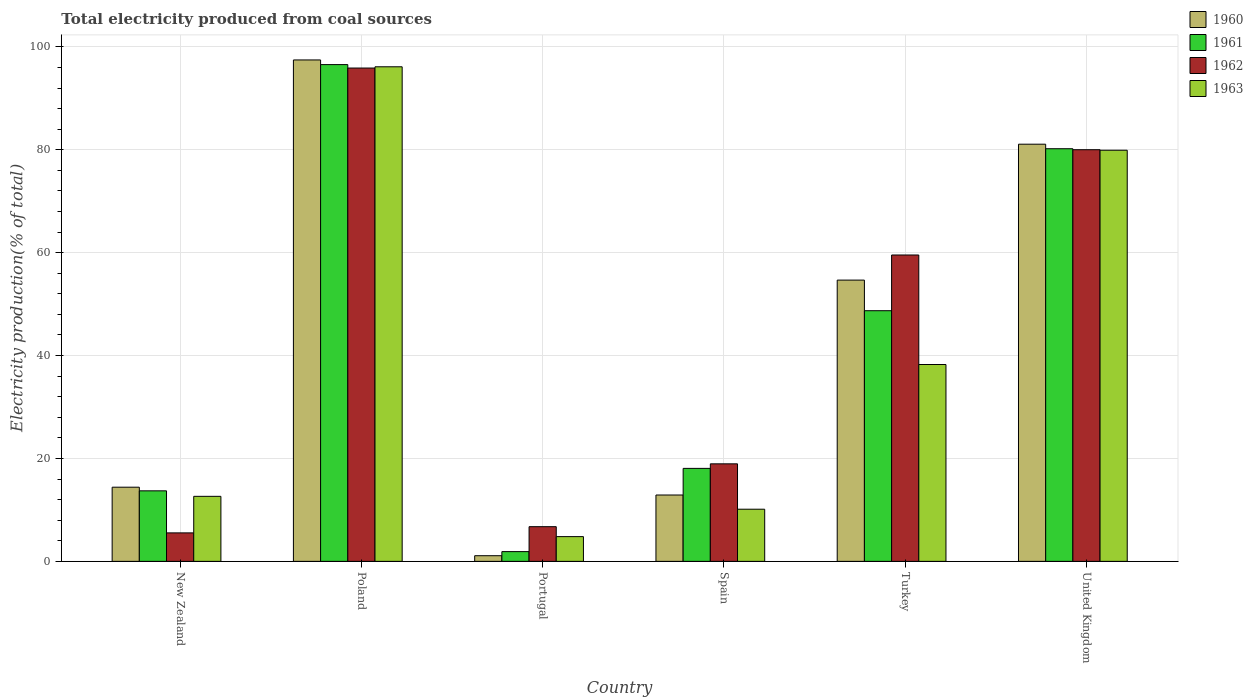How many bars are there on the 3rd tick from the left?
Keep it short and to the point. 4. What is the label of the 4th group of bars from the left?
Provide a succinct answer. Spain. In how many cases, is the number of bars for a given country not equal to the number of legend labels?
Offer a very short reply. 0. What is the total electricity produced in 1960 in Turkey?
Provide a succinct answer. 54.67. Across all countries, what is the maximum total electricity produced in 1960?
Your answer should be compact. 97.46. Across all countries, what is the minimum total electricity produced in 1961?
Ensure brevity in your answer.  1.89. What is the total total electricity produced in 1963 in the graph?
Provide a succinct answer. 241.89. What is the difference between the total electricity produced in 1960 in Turkey and that in United Kingdom?
Make the answer very short. -26.41. What is the difference between the total electricity produced in 1960 in New Zealand and the total electricity produced in 1961 in Portugal?
Provide a succinct answer. 12.52. What is the average total electricity produced in 1963 per country?
Provide a succinct answer. 40.32. What is the difference between the total electricity produced of/in 1963 and total electricity produced of/in 1961 in Portugal?
Your answer should be very brief. 2.91. What is the ratio of the total electricity produced in 1962 in Poland to that in United Kingdom?
Provide a succinct answer. 1.2. Is the total electricity produced in 1960 in New Zealand less than that in Portugal?
Keep it short and to the point. No. Is the difference between the total electricity produced in 1963 in Portugal and Turkey greater than the difference between the total electricity produced in 1961 in Portugal and Turkey?
Make the answer very short. Yes. What is the difference between the highest and the second highest total electricity produced in 1960?
Offer a very short reply. -16.38. What is the difference between the highest and the lowest total electricity produced in 1963?
Your answer should be compact. 91.32. In how many countries, is the total electricity produced in 1963 greater than the average total electricity produced in 1963 taken over all countries?
Provide a short and direct response. 2. Is the sum of the total electricity produced in 1962 in New Zealand and Turkey greater than the maximum total electricity produced in 1963 across all countries?
Offer a terse response. No. Is it the case that in every country, the sum of the total electricity produced in 1963 and total electricity produced in 1961 is greater than the sum of total electricity produced in 1960 and total electricity produced in 1962?
Your answer should be very brief. No. What does the 4th bar from the left in United Kingdom represents?
Offer a very short reply. 1963. What does the 2nd bar from the right in New Zealand represents?
Provide a short and direct response. 1962. How many bars are there?
Your response must be concise. 24. Are all the bars in the graph horizontal?
Your answer should be very brief. No. How many countries are there in the graph?
Make the answer very short. 6. Does the graph contain any zero values?
Ensure brevity in your answer.  No. Where does the legend appear in the graph?
Your response must be concise. Top right. How many legend labels are there?
Your response must be concise. 4. What is the title of the graph?
Your answer should be compact. Total electricity produced from coal sources. What is the label or title of the Y-axis?
Offer a very short reply. Electricity production(% of total). What is the Electricity production(% of total) of 1960 in New Zealand?
Provide a short and direct response. 14.42. What is the Electricity production(% of total) in 1961 in New Zealand?
Provide a short and direct response. 13.71. What is the Electricity production(% of total) in 1962 in New Zealand?
Ensure brevity in your answer.  5.54. What is the Electricity production(% of total) of 1963 in New Zealand?
Keep it short and to the point. 12.64. What is the Electricity production(% of total) in 1960 in Poland?
Your response must be concise. 97.46. What is the Electricity production(% of total) of 1961 in Poland?
Your answer should be very brief. 96.56. What is the Electricity production(% of total) in 1962 in Poland?
Provide a succinct answer. 95.89. What is the Electricity production(% of total) of 1963 in Poland?
Provide a short and direct response. 96.13. What is the Electricity production(% of total) in 1960 in Portugal?
Your response must be concise. 1.1. What is the Electricity production(% of total) of 1961 in Portugal?
Give a very brief answer. 1.89. What is the Electricity production(% of total) of 1962 in Portugal?
Your response must be concise. 6.74. What is the Electricity production(% of total) in 1963 in Portugal?
Keep it short and to the point. 4.81. What is the Electricity production(% of total) in 1960 in Spain?
Offer a terse response. 12.9. What is the Electricity production(% of total) in 1961 in Spain?
Give a very brief answer. 18.07. What is the Electricity production(% of total) in 1962 in Spain?
Make the answer very short. 18.96. What is the Electricity production(% of total) in 1963 in Spain?
Your response must be concise. 10.14. What is the Electricity production(% of total) of 1960 in Turkey?
Provide a short and direct response. 54.67. What is the Electricity production(% of total) in 1961 in Turkey?
Offer a very short reply. 48.72. What is the Electricity production(% of total) of 1962 in Turkey?
Your response must be concise. 59.55. What is the Electricity production(% of total) in 1963 in Turkey?
Give a very brief answer. 38.26. What is the Electricity production(% of total) of 1960 in United Kingdom?
Provide a short and direct response. 81.09. What is the Electricity production(% of total) of 1961 in United Kingdom?
Offer a terse response. 80.21. What is the Electricity production(% of total) in 1962 in United Kingdom?
Provide a succinct answer. 80.01. What is the Electricity production(% of total) in 1963 in United Kingdom?
Ensure brevity in your answer.  79.91. Across all countries, what is the maximum Electricity production(% of total) in 1960?
Provide a short and direct response. 97.46. Across all countries, what is the maximum Electricity production(% of total) of 1961?
Ensure brevity in your answer.  96.56. Across all countries, what is the maximum Electricity production(% of total) in 1962?
Your answer should be very brief. 95.89. Across all countries, what is the maximum Electricity production(% of total) in 1963?
Keep it short and to the point. 96.13. Across all countries, what is the minimum Electricity production(% of total) in 1960?
Keep it short and to the point. 1.1. Across all countries, what is the minimum Electricity production(% of total) in 1961?
Your answer should be compact. 1.89. Across all countries, what is the minimum Electricity production(% of total) in 1962?
Keep it short and to the point. 5.54. Across all countries, what is the minimum Electricity production(% of total) of 1963?
Provide a short and direct response. 4.81. What is the total Electricity production(% of total) of 1960 in the graph?
Your answer should be very brief. 261.63. What is the total Electricity production(% of total) in 1961 in the graph?
Ensure brevity in your answer.  259.16. What is the total Electricity production(% of total) of 1962 in the graph?
Your response must be concise. 266.69. What is the total Electricity production(% of total) in 1963 in the graph?
Make the answer very short. 241.89. What is the difference between the Electricity production(% of total) in 1960 in New Zealand and that in Poland?
Offer a terse response. -83.05. What is the difference between the Electricity production(% of total) of 1961 in New Zealand and that in Poland?
Make the answer very short. -82.85. What is the difference between the Electricity production(% of total) in 1962 in New Zealand and that in Poland?
Your answer should be compact. -90.35. What is the difference between the Electricity production(% of total) in 1963 in New Zealand and that in Poland?
Make the answer very short. -83.49. What is the difference between the Electricity production(% of total) of 1960 in New Zealand and that in Portugal?
Provide a succinct answer. 13.32. What is the difference between the Electricity production(% of total) of 1961 in New Zealand and that in Portugal?
Offer a very short reply. 11.81. What is the difference between the Electricity production(% of total) in 1962 in New Zealand and that in Portugal?
Your response must be concise. -1.2. What is the difference between the Electricity production(% of total) in 1963 in New Zealand and that in Portugal?
Your answer should be compact. 7.83. What is the difference between the Electricity production(% of total) in 1960 in New Zealand and that in Spain?
Your answer should be compact. 1.52. What is the difference between the Electricity production(% of total) of 1961 in New Zealand and that in Spain?
Offer a terse response. -4.36. What is the difference between the Electricity production(% of total) in 1962 in New Zealand and that in Spain?
Your answer should be compact. -13.42. What is the difference between the Electricity production(% of total) in 1963 in New Zealand and that in Spain?
Keep it short and to the point. 2.5. What is the difference between the Electricity production(% of total) in 1960 in New Zealand and that in Turkey?
Provide a short and direct response. -40.25. What is the difference between the Electricity production(% of total) of 1961 in New Zealand and that in Turkey?
Offer a terse response. -35.01. What is the difference between the Electricity production(% of total) in 1962 in New Zealand and that in Turkey?
Give a very brief answer. -54.01. What is the difference between the Electricity production(% of total) in 1963 in New Zealand and that in Turkey?
Ensure brevity in your answer.  -25.62. What is the difference between the Electricity production(% of total) in 1960 in New Zealand and that in United Kingdom?
Make the answer very short. -66.67. What is the difference between the Electricity production(% of total) of 1961 in New Zealand and that in United Kingdom?
Offer a very short reply. -66.5. What is the difference between the Electricity production(% of total) in 1962 in New Zealand and that in United Kingdom?
Keep it short and to the point. -74.48. What is the difference between the Electricity production(% of total) of 1963 in New Zealand and that in United Kingdom?
Provide a succinct answer. -67.27. What is the difference between the Electricity production(% of total) of 1960 in Poland and that in Portugal?
Your answer should be compact. 96.36. What is the difference between the Electricity production(% of total) of 1961 in Poland and that in Portugal?
Your answer should be very brief. 94.66. What is the difference between the Electricity production(% of total) in 1962 in Poland and that in Portugal?
Your answer should be very brief. 89.15. What is the difference between the Electricity production(% of total) of 1963 in Poland and that in Portugal?
Ensure brevity in your answer.  91.32. What is the difference between the Electricity production(% of total) of 1960 in Poland and that in Spain?
Ensure brevity in your answer.  84.56. What is the difference between the Electricity production(% of total) in 1961 in Poland and that in Spain?
Offer a terse response. 78.49. What is the difference between the Electricity production(% of total) in 1962 in Poland and that in Spain?
Ensure brevity in your answer.  76.93. What is the difference between the Electricity production(% of total) of 1963 in Poland and that in Spain?
Provide a succinct answer. 86. What is the difference between the Electricity production(% of total) in 1960 in Poland and that in Turkey?
Your answer should be compact. 42.79. What is the difference between the Electricity production(% of total) of 1961 in Poland and that in Turkey?
Your response must be concise. 47.84. What is the difference between the Electricity production(% of total) in 1962 in Poland and that in Turkey?
Provide a succinct answer. 36.34. What is the difference between the Electricity production(% of total) in 1963 in Poland and that in Turkey?
Offer a terse response. 57.87. What is the difference between the Electricity production(% of total) of 1960 in Poland and that in United Kingdom?
Offer a very short reply. 16.38. What is the difference between the Electricity production(% of total) in 1961 in Poland and that in United Kingdom?
Offer a terse response. 16.35. What is the difference between the Electricity production(% of total) in 1962 in Poland and that in United Kingdom?
Your response must be concise. 15.87. What is the difference between the Electricity production(% of total) in 1963 in Poland and that in United Kingdom?
Offer a terse response. 16.22. What is the difference between the Electricity production(% of total) in 1960 in Portugal and that in Spain?
Your answer should be compact. -11.8. What is the difference between the Electricity production(% of total) of 1961 in Portugal and that in Spain?
Make the answer very short. -16.18. What is the difference between the Electricity production(% of total) in 1962 in Portugal and that in Spain?
Your answer should be compact. -12.22. What is the difference between the Electricity production(% of total) of 1963 in Portugal and that in Spain?
Give a very brief answer. -5.33. What is the difference between the Electricity production(% of total) in 1960 in Portugal and that in Turkey?
Make the answer very short. -53.57. What is the difference between the Electricity production(% of total) of 1961 in Portugal and that in Turkey?
Your answer should be compact. -46.83. What is the difference between the Electricity production(% of total) in 1962 in Portugal and that in Turkey?
Provide a short and direct response. -52.81. What is the difference between the Electricity production(% of total) in 1963 in Portugal and that in Turkey?
Ensure brevity in your answer.  -33.45. What is the difference between the Electricity production(% of total) of 1960 in Portugal and that in United Kingdom?
Your answer should be very brief. -79.99. What is the difference between the Electricity production(% of total) in 1961 in Portugal and that in United Kingdom?
Provide a short and direct response. -78.31. What is the difference between the Electricity production(% of total) of 1962 in Portugal and that in United Kingdom?
Make the answer very short. -73.27. What is the difference between the Electricity production(% of total) in 1963 in Portugal and that in United Kingdom?
Make the answer very short. -75.1. What is the difference between the Electricity production(% of total) in 1960 in Spain and that in Turkey?
Your answer should be compact. -41.77. What is the difference between the Electricity production(% of total) of 1961 in Spain and that in Turkey?
Your answer should be very brief. -30.65. What is the difference between the Electricity production(% of total) in 1962 in Spain and that in Turkey?
Offer a very short reply. -40.59. What is the difference between the Electricity production(% of total) of 1963 in Spain and that in Turkey?
Offer a very short reply. -28.13. What is the difference between the Electricity production(% of total) of 1960 in Spain and that in United Kingdom?
Provide a short and direct response. -68.19. What is the difference between the Electricity production(% of total) in 1961 in Spain and that in United Kingdom?
Give a very brief answer. -62.14. What is the difference between the Electricity production(% of total) of 1962 in Spain and that in United Kingdom?
Your response must be concise. -61.06. What is the difference between the Electricity production(% of total) in 1963 in Spain and that in United Kingdom?
Keep it short and to the point. -69.78. What is the difference between the Electricity production(% of total) in 1960 in Turkey and that in United Kingdom?
Your response must be concise. -26.41. What is the difference between the Electricity production(% of total) in 1961 in Turkey and that in United Kingdom?
Provide a succinct answer. -31.49. What is the difference between the Electricity production(% of total) in 1962 in Turkey and that in United Kingdom?
Ensure brevity in your answer.  -20.46. What is the difference between the Electricity production(% of total) of 1963 in Turkey and that in United Kingdom?
Your answer should be compact. -41.65. What is the difference between the Electricity production(% of total) in 1960 in New Zealand and the Electricity production(% of total) in 1961 in Poland?
Your answer should be very brief. -82.14. What is the difference between the Electricity production(% of total) in 1960 in New Zealand and the Electricity production(% of total) in 1962 in Poland?
Ensure brevity in your answer.  -81.47. What is the difference between the Electricity production(% of total) in 1960 in New Zealand and the Electricity production(% of total) in 1963 in Poland?
Ensure brevity in your answer.  -81.71. What is the difference between the Electricity production(% of total) of 1961 in New Zealand and the Electricity production(% of total) of 1962 in Poland?
Your answer should be compact. -82.18. What is the difference between the Electricity production(% of total) of 1961 in New Zealand and the Electricity production(% of total) of 1963 in Poland?
Your answer should be compact. -82.42. What is the difference between the Electricity production(% of total) in 1962 in New Zealand and the Electricity production(% of total) in 1963 in Poland?
Your response must be concise. -90.6. What is the difference between the Electricity production(% of total) in 1960 in New Zealand and the Electricity production(% of total) in 1961 in Portugal?
Ensure brevity in your answer.  12.52. What is the difference between the Electricity production(% of total) in 1960 in New Zealand and the Electricity production(% of total) in 1962 in Portugal?
Offer a very short reply. 7.68. What is the difference between the Electricity production(% of total) in 1960 in New Zealand and the Electricity production(% of total) in 1963 in Portugal?
Provide a succinct answer. 9.61. What is the difference between the Electricity production(% of total) in 1961 in New Zealand and the Electricity production(% of total) in 1962 in Portugal?
Provide a succinct answer. 6.97. What is the difference between the Electricity production(% of total) in 1961 in New Zealand and the Electricity production(% of total) in 1963 in Portugal?
Provide a short and direct response. 8.9. What is the difference between the Electricity production(% of total) in 1962 in New Zealand and the Electricity production(% of total) in 1963 in Portugal?
Offer a very short reply. 0.73. What is the difference between the Electricity production(% of total) in 1960 in New Zealand and the Electricity production(% of total) in 1961 in Spain?
Offer a terse response. -3.65. What is the difference between the Electricity production(% of total) in 1960 in New Zealand and the Electricity production(% of total) in 1962 in Spain?
Keep it short and to the point. -4.54. What is the difference between the Electricity production(% of total) of 1960 in New Zealand and the Electricity production(% of total) of 1963 in Spain?
Provide a short and direct response. 4.28. What is the difference between the Electricity production(% of total) of 1961 in New Zealand and the Electricity production(% of total) of 1962 in Spain?
Make the answer very short. -5.25. What is the difference between the Electricity production(% of total) in 1961 in New Zealand and the Electricity production(% of total) in 1963 in Spain?
Ensure brevity in your answer.  3.57. What is the difference between the Electricity production(% of total) in 1962 in New Zealand and the Electricity production(% of total) in 1963 in Spain?
Offer a terse response. -4.6. What is the difference between the Electricity production(% of total) of 1960 in New Zealand and the Electricity production(% of total) of 1961 in Turkey?
Keep it short and to the point. -34.3. What is the difference between the Electricity production(% of total) of 1960 in New Zealand and the Electricity production(% of total) of 1962 in Turkey?
Make the answer very short. -45.13. What is the difference between the Electricity production(% of total) in 1960 in New Zealand and the Electricity production(% of total) in 1963 in Turkey?
Provide a succinct answer. -23.85. What is the difference between the Electricity production(% of total) of 1961 in New Zealand and the Electricity production(% of total) of 1962 in Turkey?
Your response must be concise. -45.84. What is the difference between the Electricity production(% of total) in 1961 in New Zealand and the Electricity production(% of total) in 1963 in Turkey?
Provide a short and direct response. -24.55. What is the difference between the Electricity production(% of total) of 1962 in New Zealand and the Electricity production(% of total) of 1963 in Turkey?
Ensure brevity in your answer.  -32.73. What is the difference between the Electricity production(% of total) in 1960 in New Zealand and the Electricity production(% of total) in 1961 in United Kingdom?
Keep it short and to the point. -65.79. What is the difference between the Electricity production(% of total) of 1960 in New Zealand and the Electricity production(% of total) of 1962 in United Kingdom?
Provide a succinct answer. -65.6. What is the difference between the Electricity production(% of total) in 1960 in New Zealand and the Electricity production(% of total) in 1963 in United Kingdom?
Ensure brevity in your answer.  -65.5. What is the difference between the Electricity production(% of total) in 1961 in New Zealand and the Electricity production(% of total) in 1962 in United Kingdom?
Ensure brevity in your answer.  -66.31. What is the difference between the Electricity production(% of total) of 1961 in New Zealand and the Electricity production(% of total) of 1963 in United Kingdom?
Provide a short and direct response. -66.21. What is the difference between the Electricity production(% of total) of 1962 in New Zealand and the Electricity production(% of total) of 1963 in United Kingdom?
Keep it short and to the point. -74.38. What is the difference between the Electricity production(% of total) of 1960 in Poland and the Electricity production(% of total) of 1961 in Portugal?
Your response must be concise. 95.57. What is the difference between the Electricity production(% of total) in 1960 in Poland and the Electricity production(% of total) in 1962 in Portugal?
Your answer should be very brief. 90.72. What is the difference between the Electricity production(% of total) of 1960 in Poland and the Electricity production(% of total) of 1963 in Portugal?
Your response must be concise. 92.65. What is the difference between the Electricity production(% of total) of 1961 in Poland and the Electricity production(% of total) of 1962 in Portugal?
Provide a succinct answer. 89.82. What is the difference between the Electricity production(% of total) in 1961 in Poland and the Electricity production(% of total) in 1963 in Portugal?
Give a very brief answer. 91.75. What is the difference between the Electricity production(% of total) of 1962 in Poland and the Electricity production(% of total) of 1963 in Portugal?
Provide a succinct answer. 91.08. What is the difference between the Electricity production(% of total) in 1960 in Poland and the Electricity production(% of total) in 1961 in Spain?
Your answer should be very brief. 79.39. What is the difference between the Electricity production(% of total) of 1960 in Poland and the Electricity production(% of total) of 1962 in Spain?
Your answer should be compact. 78.51. What is the difference between the Electricity production(% of total) of 1960 in Poland and the Electricity production(% of total) of 1963 in Spain?
Keep it short and to the point. 87.33. What is the difference between the Electricity production(% of total) in 1961 in Poland and the Electricity production(% of total) in 1962 in Spain?
Make the answer very short. 77.6. What is the difference between the Electricity production(% of total) in 1961 in Poland and the Electricity production(% of total) in 1963 in Spain?
Provide a succinct answer. 86.42. What is the difference between the Electricity production(% of total) in 1962 in Poland and the Electricity production(% of total) in 1963 in Spain?
Your response must be concise. 85.75. What is the difference between the Electricity production(% of total) of 1960 in Poland and the Electricity production(% of total) of 1961 in Turkey?
Provide a short and direct response. 48.74. What is the difference between the Electricity production(% of total) in 1960 in Poland and the Electricity production(% of total) in 1962 in Turkey?
Your answer should be very brief. 37.91. What is the difference between the Electricity production(% of total) in 1960 in Poland and the Electricity production(% of total) in 1963 in Turkey?
Offer a very short reply. 59.2. What is the difference between the Electricity production(% of total) of 1961 in Poland and the Electricity production(% of total) of 1962 in Turkey?
Your response must be concise. 37.01. What is the difference between the Electricity production(% of total) of 1961 in Poland and the Electricity production(% of total) of 1963 in Turkey?
Your response must be concise. 58.29. What is the difference between the Electricity production(% of total) of 1962 in Poland and the Electricity production(% of total) of 1963 in Turkey?
Your answer should be very brief. 57.63. What is the difference between the Electricity production(% of total) in 1960 in Poland and the Electricity production(% of total) in 1961 in United Kingdom?
Provide a short and direct response. 17.26. What is the difference between the Electricity production(% of total) of 1960 in Poland and the Electricity production(% of total) of 1962 in United Kingdom?
Offer a terse response. 17.45. What is the difference between the Electricity production(% of total) of 1960 in Poland and the Electricity production(% of total) of 1963 in United Kingdom?
Your answer should be compact. 17.55. What is the difference between the Electricity production(% of total) in 1961 in Poland and the Electricity production(% of total) in 1962 in United Kingdom?
Give a very brief answer. 16.54. What is the difference between the Electricity production(% of total) in 1961 in Poland and the Electricity production(% of total) in 1963 in United Kingdom?
Offer a terse response. 16.64. What is the difference between the Electricity production(% of total) of 1962 in Poland and the Electricity production(% of total) of 1963 in United Kingdom?
Ensure brevity in your answer.  15.97. What is the difference between the Electricity production(% of total) in 1960 in Portugal and the Electricity production(% of total) in 1961 in Spain?
Your answer should be very brief. -16.97. What is the difference between the Electricity production(% of total) of 1960 in Portugal and the Electricity production(% of total) of 1962 in Spain?
Provide a short and direct response. -17.86. What is the difference between the Electricity production(% of total) in 1960 in Portugal and the Electricity production(% of total) in 1963 in Spain?
Your answer should be compact. -9.04. What is the difference between the Electricity production(% of total) of 1961 in Portugal and the Electricity production(% of total) of 1962 in Spain?
Your answer should be compact. -17.06. What is the difference between the Electricity production(% of total) of 1961 in Portugal and the Electricity production(% of total) of 1963 in Spain?
Provide a short and direct response. -8.24. What is the difference between the Electricity production(% of total) of 1962 in Portugal and the Electricity production(% of total) of 1963 in Spain?
Offer a very short reply. -3.4. What is the difference between the Electricity production(% of total) in 1960 in Portugal and the Electricity production(% of total) in 1961 in Turkey?
Your answer should be compact. -47.62. What is the difference between the Electricity production(% of total) of 1960 in Portugal and the Electricity production(% of total) of 1962 in Turkey?
Offer a terse response. -58.45. What is the difference between the Electricity production(% of total) in 1960 in Portugal and the Electricity production(% of total) in 1963 in Turkey?
Your answer should be compact. -37.16. What is the difference between the Electricity production(% of total) of 1961 in Portugal and the Electricity production(% of total) of 1962 in Turkey?
Give a very brief answer. -57.66. What is the difference between the Electricity production(% of total) in 1961 in Portugal and the Electricity production(% of total) in 1963 in Turkey?
Your answer should be compact. -36.37. What is the difference between the Electricity production(% of total) in 1962 in Portugal and the Electricity production(% of total) in 1963 in Turkey?
Provide a succinct answer. -31.52. What is the difference between the Electricity production(% of total) of 1960 in Portugal and the Electricity production(% of total) of 1961 in United Kingdom?
Provide a short and direct response. -79.11. What is the difference between the Electricity production(% of total) of 1960 in Portugal and the Electricity production(% of total) of 1962 in United Kingdom?
Your answer should be very brief. -78.92. What is the difference between the Electricity production(% of total) in 1960 in Portugal and the Electricity production(% of total) in 1963 in United Kingdom?
Offer a very short reply. -78.82. What is the difference between the Electricity production(% of total) of 1961 in Portugal and the Electricity production(% of total) of 1962 in United Kingdom?
Provide a succinct answer. -78.12. What is the difference between the Electricity production(% of total) in 1961 in Portugal and the Electricity production(% of total) in 1963 in United Kingdom?
Your answer should be compact. -78.02. What is the difference between the Electricity production(% of total) in 1962 in Portugal and the Electricity production(% of total) in 1963 in United Kingdom?
Ensure brevity in your answer.  -73.17. What is the difference between the Electricity production(% of total) of 1960 in Spain and the Electricity production(% of total) of 1961 in Turkey?
Provide a succinct answer. -35.82. What is the difference between the Electricity production(% of total) in 1960 in Spain and the Electricity production(% of total) in 1962 in Turkey?
Ensure brevity in your answer.  -46.65. What is the difference between the Electricity production(% of total) in 1960 in Spain and the Electricity production(% of total) in 1963 in Turkey?
Your answer should be very brief. -25.36. What is the difference between the Electricity production(% of total) of 1961 in Spain and the Electricity production(% of total) of 1962 in Turkey?
Your response must be concise. -41.48. What is the difference between the Electricity production(% of total) in 1961 in Spain and the Electricity production(% of total) in 1963 in Turkey?
Provide a short and direct response. -20.19. What is the difference between the Electricity production(% of total) in 1962 in Spain and the Electricity production(% of total) in 1963 in Turkey?
Give a very brief answer. -19.31. What is the difference between the Electricity production(% of total) in 1960 in Spain and the Electricity production(% of total) in 1961 in United Kingdom?
Your answer should be very brief. -67.31. What is the difference between the Electricity production(% of total) in 1960 in Spain and the Electricity production(% of total) in 1962 in United Kingdom?
Provide a short and direct response. -67.12. What is the difference between the Electricity production(% of total) in 1960 in Spain and the Electricity production(% of total) in 1963 in United Kingdom?
Keep it short and to the point. -67.02. What is the difference between the Electricity production(% of total) of 1961 in Spain and the Electricity production(% of total) of 1962 in United Kingdom?
Your answer should be very brief. -61.94. What is the difference between the Electricity production(% of total) in 1961 in Spain and the Electricity production(% of total) in 1963 in United Kingdom?
Your answer should be compact. -61.84. What is the difference between the Electricity production(% of total) in 1962 in Spain and the Electricity production(% of total) in 1963 in United Kingdom?
Provide a short and direct response. -60.96. What is the difference between the Electricity production(% of total) of 1960 in Turkey and the Electricity production(% of total) of 1961 in United Kingdom?
Keep it short and to the point. -25.54. What is the difference between the Electricity production(% of total) of 1960 in Turkey and the Electricity production(% of total) of 1962 in United Kingdom?
Ensure brevity in your answer.  -25.34. What is the difference between the Electricity production(% of total) in 1960 in Turkey and the Electricity production(% of total) in 1963 in United Kingdom?
Make the answer very short. -25.24. What is the difference between the Electricity production(% of total) in 1961 in Turkey and the Electricity production(% of total) in 1962 in United Kingdom?
Keep it short and to the point. -31.29. What is the difference between the Electricity production(% of total) in 1961 in Turkey and the Electricity production(% of total) in 1963 in United Kingdom?
Make the answer very short. -31.19. What is the difference between the Electricity production(% of total) of 1962 in Turkey and the Electricity production(% of total) of 1963 in United Kingdom?
Offer a very short reply. -20.36. What is the average Electricity production(% of total) in 1960 per country?
Ensure brevity in your answer.  43.61. What is the average Electricity production(% of total) in 1961 per country?
Your answer should be very brief. 43.19. What is the average Electricity production(% of total) in 1962 per country?
Make the answer very short. 44.45. What is the average Electricity production(% of total) in 1963 per country?
Your answer should be compact. 40.32. What is the difference between the Electricity production(% of total) in 1960 and Electricity production(% of total) in 1961 in New Zealand?
Offer a terse response. 0.71. What is the difference between the Electricity production(% of total) of 1960 and Electricity production(% of total) of 1962 in New Zealand?
Provide a short and direct response. 8.88. What is the difference between the Electricity production(% of total) of 1960 and Electricity production(% of total) of 1963 in New Zealand?
Ensure brevity in your answer.  1.78. What is the difference between the Electricity production(% of total) of 1961 and Electricity production(% of total) of 1962 in New Zealand?
Your answer should be very brief. 8.17. What is the difference between the Electricity production(% of total) of 1961 and Electricity production(% of total) of 1963 in New Zealand?
Your response must be concise. 1.07. What is the difference between the Electricity production(% of total) in 1962 and Electricity production(% of total) in 1963 in New Zealand?
Give a very brief answer. -7.1. What is the difference between the Electricity production(% of total) in 1960 and Electricity production(% of total) in 1961 in Poland?
Your answer should be very brief. 0.91. What is the difference between the Electricity production(% of total) of 1960 and Electricity production(% of total) of 1962 in Poland?
Make the answer very short. 1.57. What is the difference between the Electricity production(% of total) of 1960 and Electricity production(% of total) of 1963 in Poland?
Offer a very short reply. 1.33. What is the difference between the Electricity production(% of total) in 1961 and Electricity production(% of total) in 1962 in Poland?
Your response must be concise. 0.67. What is the difference between the Electricity production(% of total) of 1961 and Electricity production(% of total) of 1963 in Poland?
Keep it short and to the point. 0.43. What is the difference between the Electricity production(% of total) of 1962 and Electricity production(% of total) of 1963 in Poland?
Keep it short and to the point. -0.24. What is the difference between the Electricity production(% of total) in 1960 and Electricity production(% of total) in 1961 in Portugal?
Offer a very short reply. -0.8. What is the difference between the Electricity production(% of total) in 1960 and Electricity production(% of total) in 1962 in Portugal?
Your response must be concise. -5.64. What is the difference between the Electricity production(% of total) in 1960 and Electricity production(% of total) in 1963 in Portugal?
Provide a short and direct response. -3.71. What is the difference between the Electricity production(% of total) in 1961 and Electricity production(% of total) in 1962 in Portugal?
Keep it short and to the point. -4.85. What is the difference between the Electricity production(% of total) in 1961 and Electricity production(% of total) in 1963 in Portugal?
Make the answer very short. -2.91. What is the difference between the Electricity production(% of total) in 1962 and Electricity production(% of total) in 1963 in Portugal?
Give a very brief answer. 1.93. What is the difference between the Electricity production(% of total) of 1960 and Electricity production(% of total) of 1961 in Spain?
Give a very brief answer. -5.17. What is the difference between the Electricity production(% of total) in 1960 and Electricity production(% of total) in 1962 in Spain?
Ensure brevity in your answer.  -6.06. What is the difference between the Electricity production(% of total) of 1960 and Electricity production(% of total) of 1963 in Spain?
Make the answer very short. 2.76. What is the difference between the Electricity production(% of total) of 1961 and Electricity production(% of total) of 1962 in Spain?
Offer a terse response. -0.88. What is the difference between the Electricity production(% of total) in 1961 and Electricity production(% of total) in 1963 in Spain?
Keep it short and to the point. 7.94. What is the difference between the Electricity production(% of total) in 1962 and Electricity production(% of total) in 1963 in Spain?
Give a very brief answer. 8.82. What is the difference between the Electricity production(% of total) in 1960 and Electricity production(% of total) in 1961 in Turkey?
Provide a succinct answer. 5.95. What is the difference between the Electricity production(% of total) of 1960 and Electricity production(% of total) of 1962 in Turkey?
Keep it short and to the point. -4.88. What is the difference between the Electricity production(% of total) of 1960 and Electricity production(% of total) of 1963 in Turkey?
Your answer should be very brief. 16.41. What is the difference between the Electricity production(% of total) in 1961 and Electricity production(% of total) in 1962 in Turkey?
Ensure brevity in your answer.  -10.83. What is the difference between the Electricity production(% of total) in 1961 and Electricity production(% of total) in 1963 in Turkey?
Offer a terse response. 10.46. What is the difference between the Electricity production(% of total) of 1962 and Electricity production(% of total) of 1963 in Turkey?
Your answer should be compact. 21.29. What is the difference between the Electricity production(% of total) of 1960 and Electricity production(% of total) of 1961 in United Kingdom?
Ensure brevity in your answer.  0.88. What is the difference between the Electricity production(% of total) in 1960 and Electricity production(% of total) in 1962 in United Kingdom?
Your answer should be very brief. 1.07. What is the difference between the Electricity production(% of total) of 1960 and Electricity production(% of total) of 1963 in United Kingdom?
Your response must be concise. 1.17. What is the difference between the Electricity production(% of total) of 1961 and Electricity production(% of total) of 1962 in United Kingdom?
Make the answer very short. 0.19. What is the difference between the Electricity production(% of total) in 1961 and Electricity production(% of total) in 1963 in United Kingdom?
Give a very brief answer. 0.29. What is the difference between the Electricity production(% of total) in 1962 and Electricity production(% of total) in 1963 in United Kingdom?
Keep it short and to the point. 0.1. What is the ratio of the Electricity production(% of total) in 1960 in New Zealand to that in Poland?
Offer a very short reply. 0.15. What is the ratio of the Electricity production(% of total) in 1961 in New Zealand to that in Poland?
Ensure brevity in your answer.  0.14. What is the ratio of the Electricity production(% of total) in 1962 in New Zealand to that in Poland?
Ensure brevity in your answer.  0.06. What is the ratio of the Electricity production(% of total) in 1963 in New Zealand to that in Poland?
Your response must be concise. 0.13. What is the ratio of the Electricity production(% of total) in 1960 in New Zealand to that in Portugal?
Your answer should be compact. 13.13. What is the ratio of the Electricity production(% of total) of 1961 in New Zealand to that in Portugal?
Offer a very short reply. 7.24. What is the ratio of the Electricity production(% of total) in 1962 in New Zealand to that in Portugal?
Provide a short and direct response. 0.82. What is the ratio of the Electricity production(% of total) in 1963 in New Zealand to that in Portugal?
Your answer should be compact. 2.63. What is the ratio of the Electricity production(% of total) in 1960 in New Zealand to that in Spain?
Give a very brief answer. 1.12. What is the ratio of the Electricity production(% of total) of 1961 in New Zealand to that in Spain?
Your response must be concise. 0.76. What is the ratio of the Electricity production(% of total) in 1962 in New Zealand to that in Spain?
Offer a terse response. 0.29. What is the ratio of the Electricity production(% of total) in 1963 in New Zealand to that in Spain?
Provide a short and direct response. 1.25. What is the ratio of the Electricity production(% of total) in 1960 in New Zealand to that in Turkey?
Provide a succinct answer. 0.26. What is the ratio of the Electricity production(% of total) of 1961 in New Zealand to that in Turkey?
Provide a succinct answer. 0.28. What is the ratio of the Electricity production(% of total) in 1962 in New Zealand to that in Turkey?
Your answer should be compact. 0.09. What is the ratio of the Electricity production(% of total) of 1963 in New Zealand to that in Turkey?
Keep it short and to the point. 0.33. What is the ratio of the Electricity production(% of total) of 1960 in New Zealand to that in United Kingdom?
Make the answer very short. 0.18. What is the ratio of the Electricity production(% of total) of 1961 in New Zealand to that in United Kingdom?
Make the answer very short. 0.17. What is the ratio of the Electricity production(% of total) of 1962 in New Zealand to that in United Kingdom?
Your response must be concise. 0.07. What is the ratio of the Electricity production(% of total) of 1963 in New Zealand to that in United Kingdom?
Offer a very short reply. 0.16. What is the ratio of the Electricity production(% of total) of 1960 in Poland to that in Portugal?
Your answer should be compact. 88.77. What is the ratio of the Electricity production(% of total) in 1961 in Poland to that in Portugal?
Your answer should be very brief. 50.97. What is the ratio of the Electricity production(% of total) in 1962 in Poland to that in Portugal?
Give a very brief answer. 14.23. What is the ratio of the Electricity production(% of total) of 1963 in Poland to that in Portugal?
Provide a succinct answer. 19.99. What is the ratio of the Electricity production(% of total) of 1960 in Poland to that in Spain?
Your answer should be very brief. 7.56. What is the ratio of the Electricity production(% of total) in 1961 in Poland to that in Spain?
Offer a terse response. 5.34. What is the ratio of the Electricity production(% of total) of 1962 in Poland to that in Spain?
Your response must be concise. 5.06. What is the ratio of the Electricity production(% of total) of 1963 in Poland to that in Spain?
Your answer should be very brief. 9.48. What is the ratio of the Electricity production(% of total) in 1960 in Poland to that in Turkey?
Provide a succinct answer. 1.78. What is the ratio of the Electricity production(% of total) in 1961 in Poland to that in Turkey?
Ensure brevity in your answer.  1.98. What is the ratio of the Electricity production(% of total) in 1962 in Poland to that in Turkey?
Ensure brevity in your answer.  1.61. What is the ratio of the Electricity production(% of total) in 1963 in Poland to that in Turkey?
Ensure brevity in your answer.  2.51. What is the ratio of the Electricity production(% of total) in 1960 in Poland to that in United Kingdom?
Give a very brief answer. 1.2. What is the ratio of the Electricity production(% of total) in 1961 in Poland to that in United Kingdom?
Your answer should be very brief. 1.2. What is the ratio of the Electricity production(% of total) in 1962 in Poland to that in United Kingdom?
Ensure brevity in your answer.  1.2. What is the ratio of the Electricity production(% of total) of 1963 in Poland to that in United Kingdom?
Ensure brevity in your answer.  1.2. What is the ratio of the Electricity production(% of total) in 1960 in Portugal to that in Spain?
Give a very brief answer. 0.09. What is the ratio of the Electricity production(% of total) in 1961 in Portugal to that in Spain?
Your answer should be compact. 0.1. What is the ratio of the Electricity production(% of total) of 1962 in Portugal to that in Spain?
Your answer should be very brief. 0.36. What is the ratio of the Electricity production(% of total) in 1963 in Portugal to that in Spain?
Provide a succinct answer. 0.47. What is the ratio of the Electricity production(% of total) in 1960 in Portugal to that in Turkey?
Offer a very short reply. 0.02. What is the ratio of the Electricity production(% of total) in 1961 in Portugal to that in Turkey?
Offer a terse response. 0.04. What is the ratio of the Electricity production(% of total) of 1962 in Portugal to that in Turkey?
Your response must be concise. 0.11. What is the ratio of the Electricity production(% of total) in 1963 in Portugal to that in Turkey?
Offer a very short reply. 0.13. What is the ratio of the Electricity production(% of total) of 1960 in Portugal to that in United Kingdom?
Give a very brief answer. 0.01. What is the ratio of the Electricity production(% of total) in 1961 in Portugal to that in United Kingdom?
Your answer should be compact. 0.02. What is the ratio of the Electricity production(% of total) of 1962 in Portugal to that in United Kingdom?
Your answer should be compact. 0.08. What is the ratio of the Electricity production(% of total) of 1963 in Portugal to that in United Kingdom?
Ensure brevity in your answer.  0.06. What is the ratio of the Electricity production(% of total) in 1960 in Spain to that in Turkey?
Keep it short and to the point. 0.24. What is the ratio of the Electricity production(% of total) in 1961 in Spain to that in Turkey?
Offer a terse response. 0.37. What is the ratio of the Electricity production(% of total) in 1962 in Spain to that in Turkey?
Ensure brevity in your answer.  0.32. What is the ratio of the Electricity production(% of total) in 1963 in Spain to that in Turkey?
Your answer should be compact. 0.26. What is the ratio of the Electricity production(% of total) of 1960 in Spain to that in United Kingdom?
Provide a short and direct response. 0.16. What is the ratio of the Electricity production(% of total) of 1961 in Spain to that in United Kingdom?
Provide a short and direct response. 0.23. What is the ratio of the Electricity production(% of total) in 1962 in Spain to that in United Kingdom?
Your answer should be very brief. 0.24. What is the ratio of the Electricity production(% of total) of 1963 in Spain to that in United Kingdom?
Your answer should be very brief. 0.13. What is the ratio of the Electricity production(% of total) of 1960 in Turkey to that in United Kingdom?
Ensure brevity in your answer.  0.67. What is the ratio of the Electricity production(% of total) of 1961 in Turkey to that in United Kingdom?
Give a very brief answer. 0.61. What is the ratio of the Electricity production(% of total) in 1962 in Turkey to that in United Kingdom?
Keep it short and to the point. 0.74. What is the ratio of the Electricity production(% of total) of 1963 in Turkey to that in United Kingdom?
Keep it short and to the point. 0.48. What is the difference between the highest and the second highest Electricity production(% of total) in 1960?
Keep it short and to the point. 16.38. What is the difference between the highest and the second highest Electricity production(% of total) of 1961?
Offer a very short reply. 16.35. What is the difference between the highest and the second highest Electricity production(% of total) in 1962?
Keep it short and to the point. 15.87. What is the difference between the highest and the second highest Electricity production(% of total) in 1963?
Offer a terse response. 16.22. What is the difference between the highest and the lowest Electricity production(% of total) of 1960?
Your answer should be very brief. 96.36. What is the difference between the highest and the lowest Electricity production(% of total) of 1961?
Give a very brief answer. 94.66. What is the difference between the highest and the lowest Electricity production(% of total) in 1962?
Provide a succinct answer. 90.35. What is the difference between the highest and the lowest Electricity production(% of total) in 1963?
Your answer should be very brief. 91.32. 